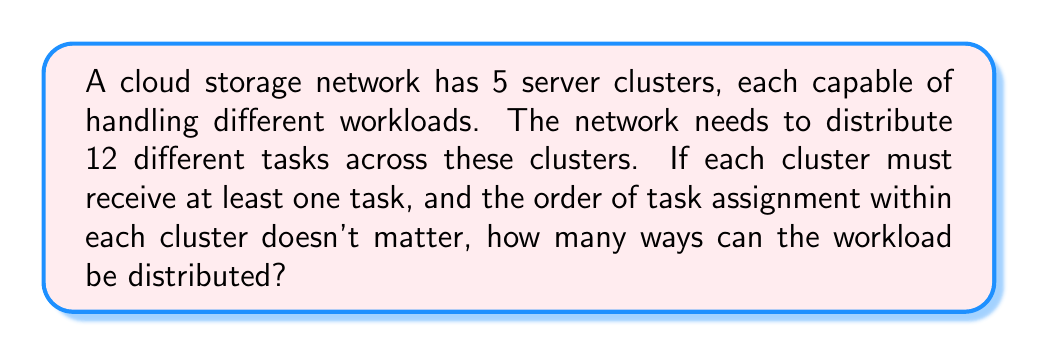Can you answer this question? To solve this problem, we can use the concept of partitions of a set and Stirling numbers of the second kind. Here's the step-by-step solution:

1) We need to distribute 12 tasks among 5 clusters, with each cluster receiving at least one task. This is equivalent to partitioning a set of 12 elements into 5 non-empty subsets.

2) The number of ways to partition a set of n elements into k non-empty subsets is given by the Stirling number of the second kind, denoted as $\stirling{n}{k}$.

3) In this case, we need to calculate $\stirling{12}{5}$.

4) The formula for Stirling numbers of the second kind is:

   $$\stirling{n}{k} = \frac{1}{k!}\sum_{i=0}^k (-1)^i \binom{k}{i}(k-i)^n$$

5) Substituting our values:

   $$\stirling{12}{5} = \frac{1}{5!}\sum_{i=0}^5 (-1)^i \binom{5}{i}(5-i)^{12}$$

6) Expanding this:
   
   $$\begin{align*}
   \stirling{12}{5} &= \frac{1}{120}[\binom{5}{0}5^{12} - \binom{5}{1}4^{12} + \binom{5}{2}3^{12} - \binom{5}{3}2^{12} + \binom{5}{4}1^{12} - \binom{5}{5}0^{12}] \\
   &= \frac{1}{120}[244140625 - 1220703125 + 1441440000 - 491520000 + 5 - 0] \\
   &= \frac{1}{120}[-26642495] \\
   &= -222020.7916...
   \end{align*}$$

7) Since we're counting ways, we take the absolute value and round to the nearest integer.
Answer: The number of ways to distribute the workload is 222,021. 